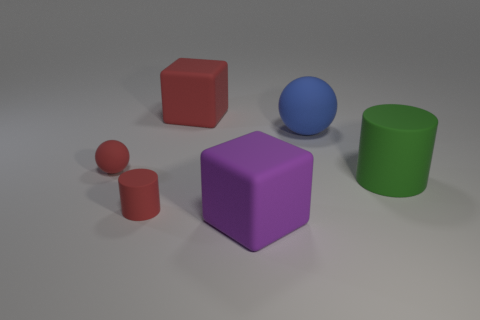What number of objects are either large gray shiny cylinders or rubber cylinders that are on the right side of the purple matte block?
Provide a short and direct response. 1. Are any tiny red spheres visible?
Ensure brevity in your answer.  Yes. What number of small rubber things have the same color as the big sphere?
Provide a succinct answer. 0. There is a small cylinder that is the same color as the small rubber sphere; what is its material?
Your answer should be very brief. Rubber. There is a sphere that is to the right of the cylinder in front of the green matte thing; what size is it?
Ensure brevity in your answer.  Large. Is there a cube that has the same material as the large green cylinder?
Make the answer very short. Yes. What is the material of the ball that is the same size as the red matte cylinder?
Your answer should be very brief. Rubber. Is the color of the big block behind the green cylinder the same as the large cube on the right side of the red rubber cube?
Make the answer very short. No. There is a matte cube behind the big green cylinder; is there a big ball that is right of it?
Your answer should be compact. Yes. Do the red matte thing that is behind the big blue matte ball and the large green matte thing that is in front of the blue ball have the same shape?
Offer a terse response. No. 